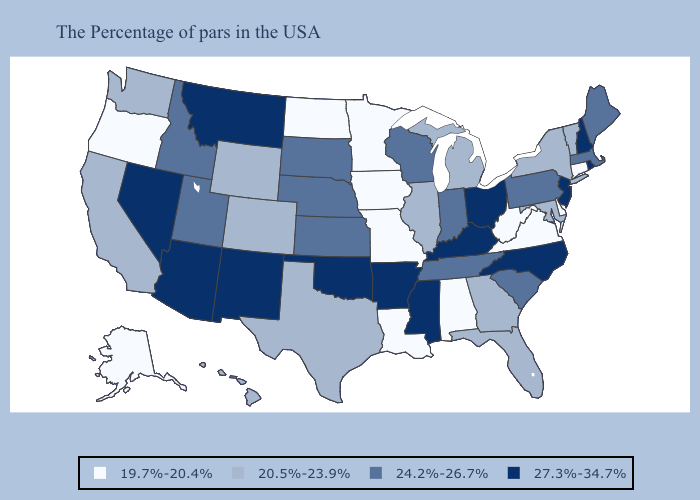What is the value of Texas?
Be succinct. 20.5%-23.9%. What is the highest value in states that border New Mexico?
Be succinct. 27.3%-34.7%. What is the lowest value in the Northeast?
Give a very brief answer. 19.7%-20.4%. Name the states that have a value in the range 27.3%-34.7%?
Quick response, please. Rhode Island, New Hampshire, New Jersey, North Carolina, Ohio, Kentucky, Mississippi, Arkansas, Oklahoma, New Mexico, Montana, Arizona, Nevada. Does Connecticut have a higher value than Oklahoma?
Write a very short answer. No. Is the legend a continuous bar?
Give a very brief answer. No. What is the value of Tennessee?
Quick response, please. 24.2%-26.7%. What is the value of New York?
Keep it brief. 20.5%-23.9%. Among the states that border Georgia , does North Carolina have the highest value?
Quick response, please. Yes. Does the map have missing data?
Keep it brief. No. What is the value of Louisiana?
Write a very short answer. 19.7%-20.4%. Name the states that have a value in the range 24.2%-26.7%?
Be succinct. Maine, Massachusetts, Pennsylvania, South Carolina, Indiana, Tennessee, Wisconsin, Kansas, Nebraska, South Dakota, Utah, Idaho. Among the states that border Nevada , which have the lowest value?
Short answer required. Oregon. What is the value of Montana?
Keep it brief. 27.3%-34.7%. Which states have the lowest value in the USA?
Write a very short answer. Connecticut, Delaware, Virginia, West Virginia, Alabama, Louisiana, Missouri, Minnesota, Iowa, North Dakota, Oregon, Alaska. 